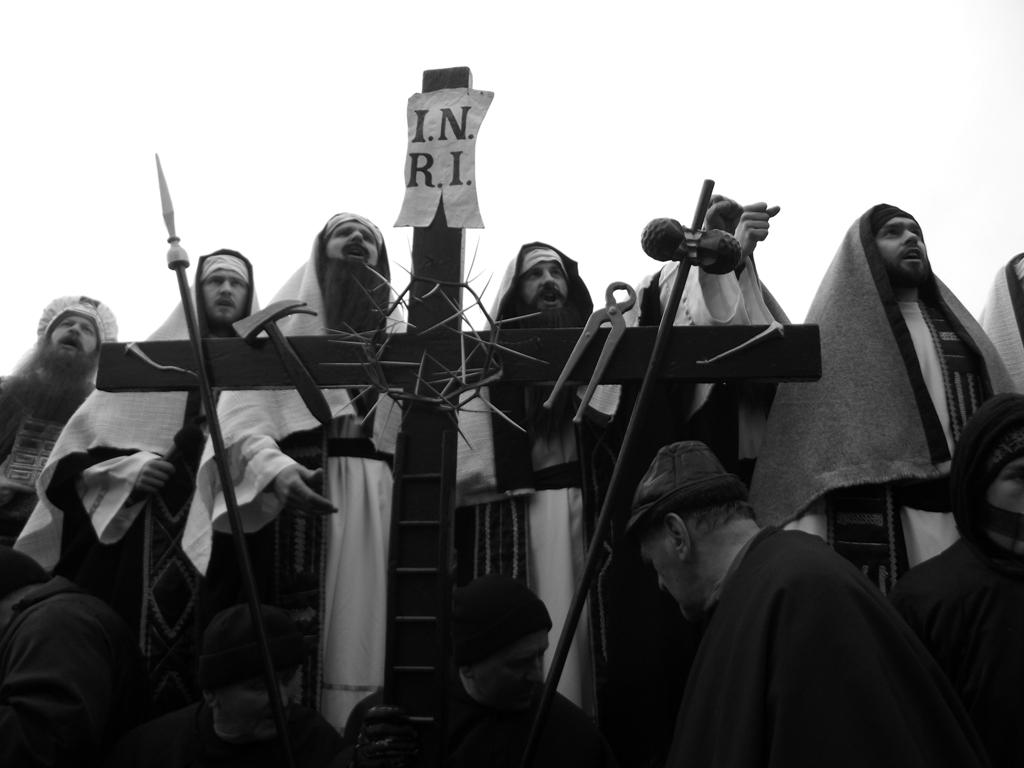What is happening at the center of the image? There are people standing at the center of the image. Can you describe the position of the person at the bottom of the image? The person at the bottom of the image is holding a cross symbol. What type of record can be seen being played by the person at the bottom of the image? There is no record present in the image; the person at the bottom is holding a cross symbol. How many bikes are visible in the image? There are no bikes visible in the image. 